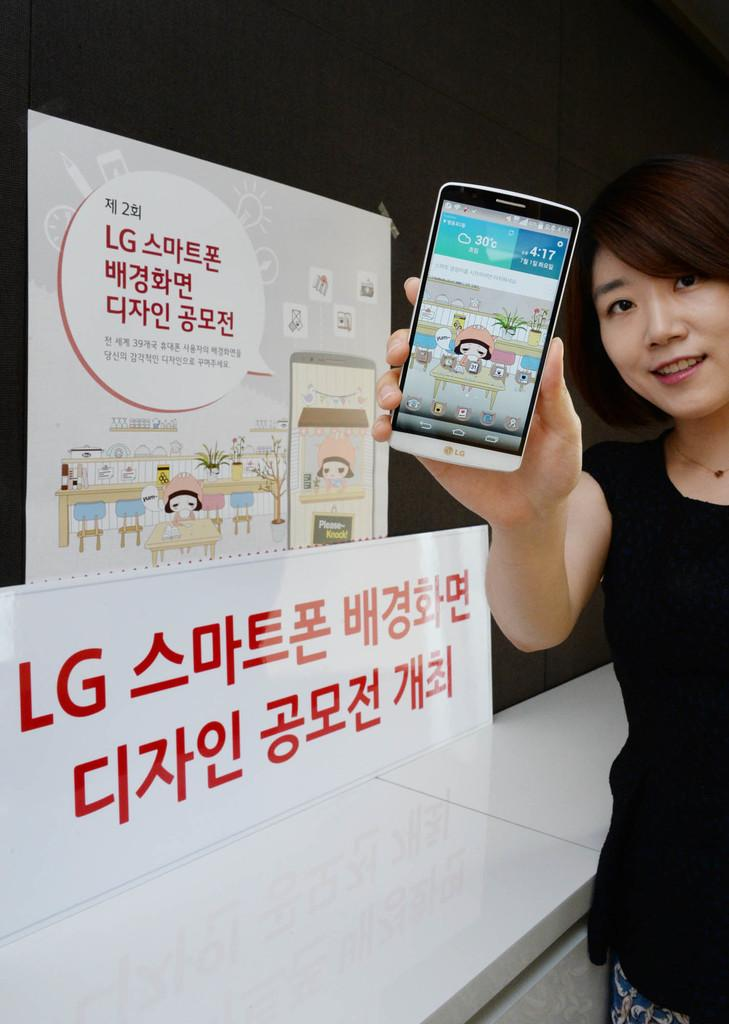Who is the main subject in the image? There is a woman in the image. What is the woman holding in her hand? The woman is holding a mobile in her hand. What can be seen in the background of the image? There is a hoarding in the background of the image. What is the position of the party in the image? There is no party present in the image, so it is not possible to determine its position. 